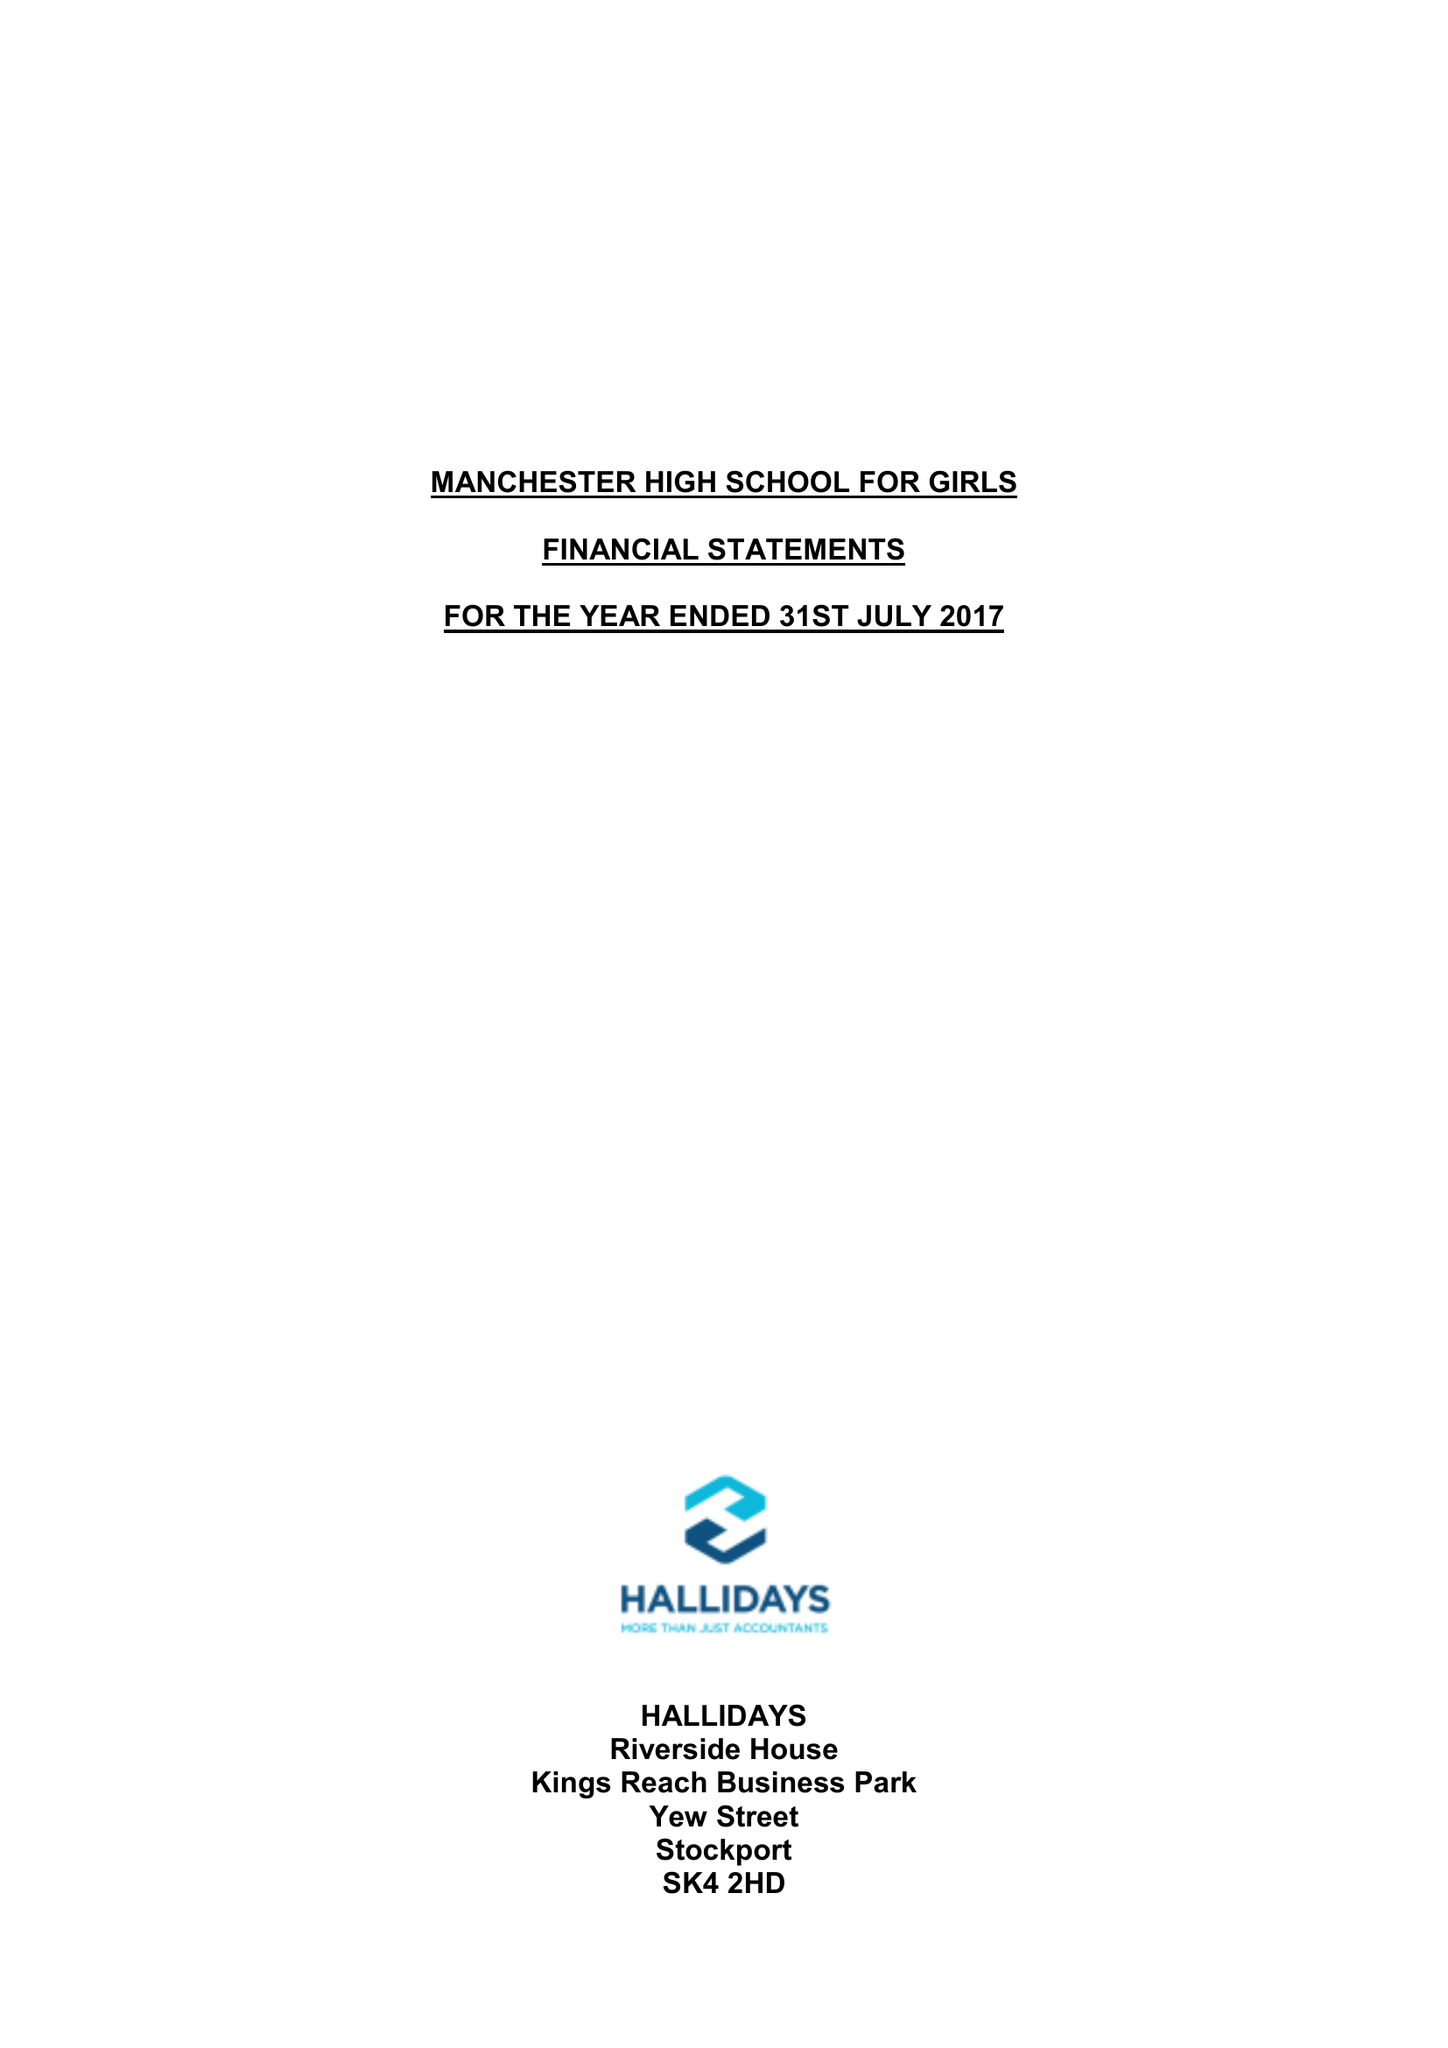What is the value for the address__postcode?
Answer the question using a single word or phrase. M14 6HS 